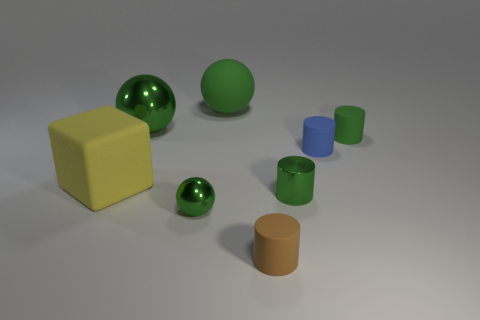There is a small blue object that is made of the same material as the brown object; what is its shape?
Give a very brief answer. Cylinder. Are there any other things that have the same shape as the large shiny object?
Your answer should be very brief. Yes. What number of small blue things are behind the big yellow matte object?
Your answer should be compact. 1. Is there a matte object?
Your response must be concise. Yes. What is the color of the large ball that is right of the shiny object left of the tiny object to the left of the small brown thing?
Offer a terse response. Green. There is a rubber cylinder in front of the big block; are there any rubber cubes that are to the right of it?
Provide a short and direct response. No. Does the matte cylinder that is in front of the big yellow thing have the same color as the rubber thing that is on the right side of the small blue object?
Your response must be concise. No. What number of other yellow objects have the same size as the yellow matte thing?
Ensure brevity in your answer.  0. Is the size of the green rubber object that is left of the brown cylinder the same as the large metal thing?
Provide a short and direct response. Yes. What is the shape of the big green matte thing?
Your answer should be compact. Sphere. 